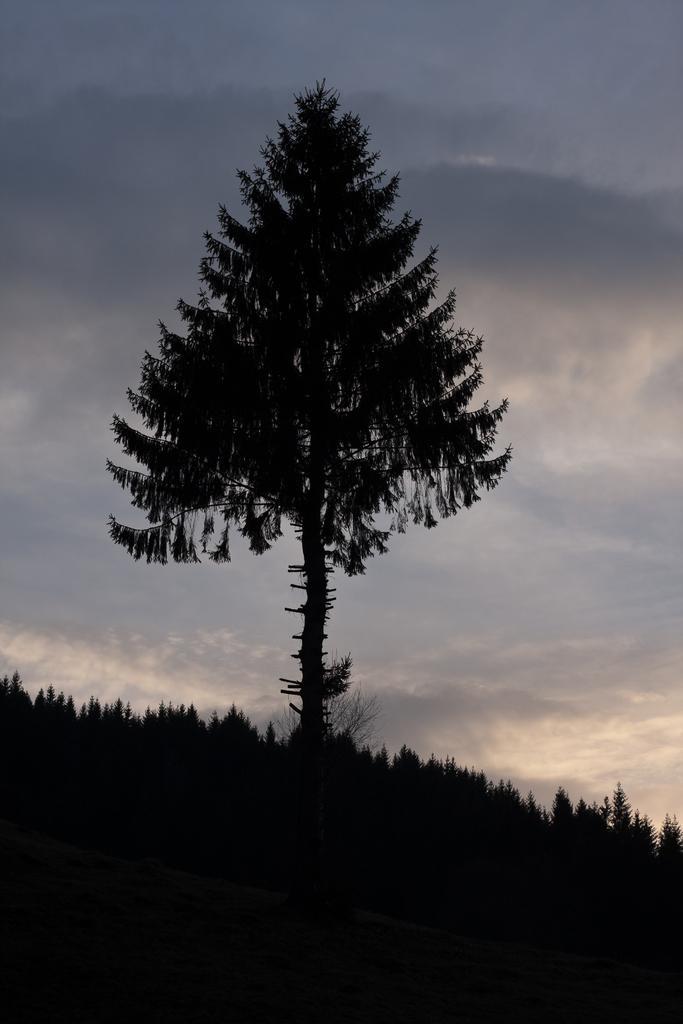In one or two sentences, can you explain what this image depicts? It looks like an evening. In the middle there is a tree, at the top it is the cloudy sky. 